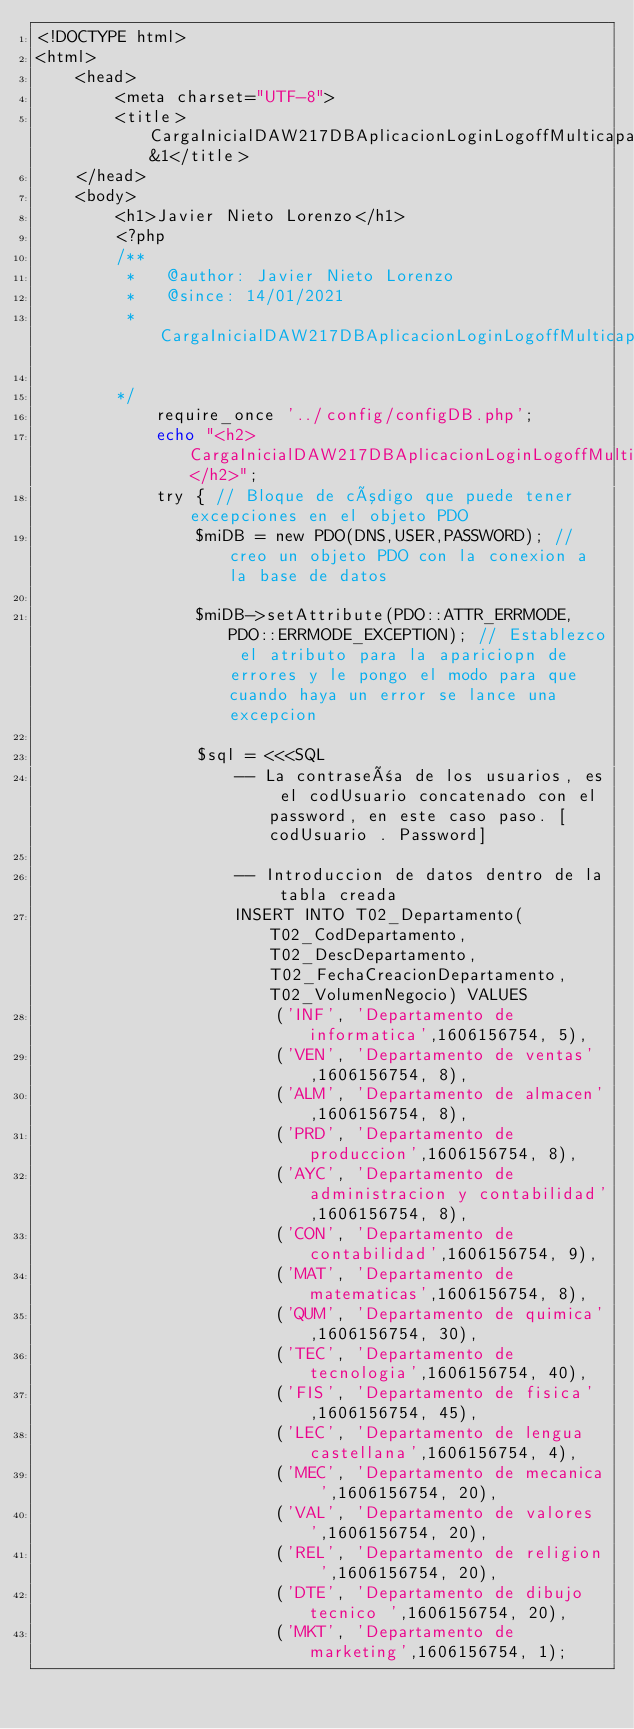Convert code to text. <code><loc_0><loc_0><loc_500><loc_500><_PHP_><!DOCTYPE html>
<html>
    <head>
        <meta charset="UTF-8">
        <title>CargaInicialDAW217DBAplicacionLoginLogoffMulticapaPOO&1</title>
    </head>
    <body>
        <h1>Javier Nieto Lorenzo</h1>
        <?php
        /**
         *   @author: Javier Nieto Lorenzo
         *   @since: 14/01/2021
         *   CargaInicialDAW217DBAplicacionLoginLogoffMulticapaPOO

        */ 
            require_once '../config/configDB.php';
            echo "<h2>CargaInicialDAW217DBAplicacionLoginLogoffMulticapaPOO</h2>";
            try { // Bloque de código que puede tener excepciones en el objeto PDO
                $miDB = new PDO(DNS,USER,PASSWORD); // creo un objeto PDO con la conexion a la base de datos
                
                $miDB->setAttribute(PDO::ATTR_ERRMODE, PDO::ERRMODE_EXCEPTION); // Establezco el atributo para la apariciopn de errores y le pongo el modo para que cuando haya un error se lance una excepcion
                
                $sql = <<<SQL
                    -- La contraseña de los usuarios, es el codUsuario concatenado con el password, en este caso paso. [codUsuario . Password]

                    -- Introduccion de datos dentro de la tabla creada
                    INSERT INTO T02_Departamento(T02_CodDepartamento, T02_DescDepartamento, T02_FechaCreacionDepartamento, T02_VolumenNegocio) VALUES
                        ('INF', 'Departamento de informatica',1606156754, 5),
                        ('VEN', 'Departamento de ventas',1606156754, 8),
                        ('ALM', 'Departamento de almacen',1606156754, 8),
                        ('PRD', 'Departamento de produccion',1606156754, 8),
                        ('AYC', 'Departamento de administracion y contabilidad',1606156754, 8),
                        ('CON', 'Departamento de contabilidad',1606156754, 9),
                        ('MAT', 'Departamento de matematicas',1606156754, 8),
                        ('QUM', 'Departamento de quimica',1606156754, 30),
                        ('TEC', 'Departamento de tecnologia',1606156754, 40),
                        ('FIS', 'Departamento de fisica',1606156754, 45),
                        ('LEC', 'Departamento de lengua castellana',1606156754, 4),
                        ('MEC', 'Departamento de mecanica ',1606156754, 20),
                        ('VAL', 'Departamento de valores ',1606156754, 20),
                        ('REL', 'Departamento de religion ',1606156754, 20),
                        ('DTE', 'Departamento de dibujo tecnico ',1606156754, 20),
                        ('MKT', 'Departamento de marketing',1606156754, 1);</code> 